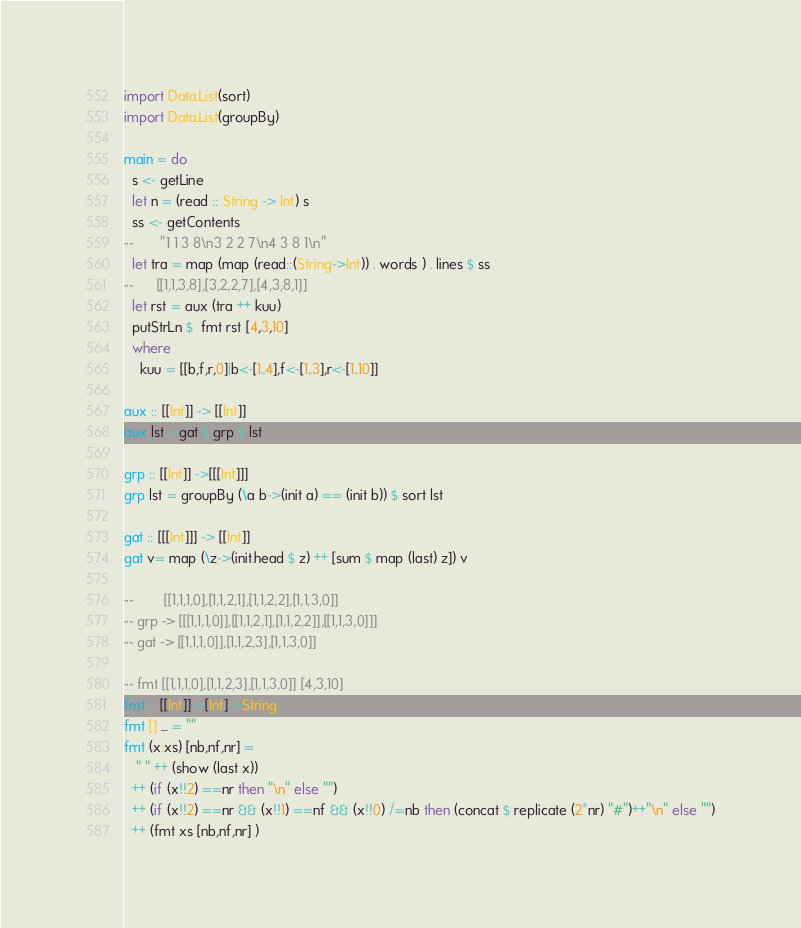<code> <loc_0><loc_0><loc_500><loc_500><_Haskell_>import Data.List(sort)
import Data.List(groupBy)

main = do
  s <- getLine
  let n = (read :: String -> Int) s
  ss <- getContents
--       "1 1 3 8\n3 2 2 7\n4 3 8 1\n"
  let tra = map (map (read::(String->Int)) . words ) . lines $ ss
--      [[1,1,3,8],[3,2,2,7],[4,3,8,1]]
  let rst = aux (tra ++ kuu)
  putStrLn $  fmt rst [4,3,10]
  where
    kuu = [[b,f,r,0]|b<-[1..4],f<-[1..3],r<-[1..10]]

aux :: [[Int]] -> [[Int]]
aux lst =gat $ grp $ lst

grp :: [[Int]] ->[[[Int]]]   
grp lst = groupBy (\a b->(init a) == (init b)) $ sort lst

gat :: [[[Int]]] -> [[Int]]
gat v= map (\z->(init.head $ z) ++ [sum $ map (last) z]) v

--        [[1,1,1,0],[1,1,2,1],[1,1,2,2],[1,1,3,0]]
-- grp -> [[[1,1,1,0]],[[1,1,2,1],[1,1,2,2]],[[1,1,3,0]]]
-- gat -> [[1,1,1,0]],[1,1,2,3],[1,1,3,0]]

-- fmt [[1,1,1,0],[1,1,2,3],[1,1,3,0]] [4,3,10]
fmt :: [[Int]]->[Int]->String
fmt [] _ = ""
fmt (x:xs) [nb,nf,nr] =
   " " ++ (show (last x))
  ++ (if (x!!2) ==nr then "\n" else "") 
  ++ (if (x!!2) ==nr && (x!!1) ==nf && (x!!0) /=nb then (concat $ replicate (2*nr) "#")++"\n" else "")
  ++ (fmt xs [nb,nf,nr] )</code> 